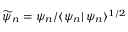Convert formula to latex. <formula><loc_0><loc_0><loc_500><loc_500>\widetilde { \psi } _ { n } = \psi _ { n } / \langle \psi _ { n } | \, \psi _ { n } \rangle ^ { 1 / 2 }</formula> 